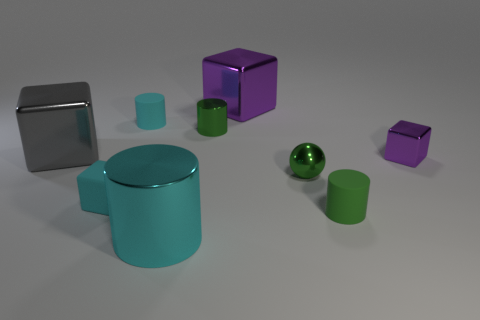There is another shiny object that is the same shape as the large cyan object; what is its color?
Give a very brief answer. Green. How many objects are in front of the tiny purple shiny object and left of the green matte cylinder?
Keep it short and to the point. 3. Is the number of tiny green metal spheres behind the large gray metallic block greater than the number of green cylinders behind the green metal cylinder?
Offer a very short reply. No. What is the size of the gray thing?
Offer a very short reply. Large. Is there a large green metal object of the same shape as the gray object?
Offer a terse response. No. There is a large cyan shiny object; is it the same shape as the rubber thing that is on the right side of the small ball?
Your answer should be compact. Yes. There is a thing that is both right of the tiny green shiny sphere and behind the rubber block; how big is it?
Keep it short and to the point. Small. What number of tiny purple things are there?
Your response must be concise. 1. What is the material of the cyan cylinder that is the same size as the green metallic ball?
Offer a very short reply. Rubber. Is there a brown ball that has the same size as the green matte object?
Offer a very short reply. No. 